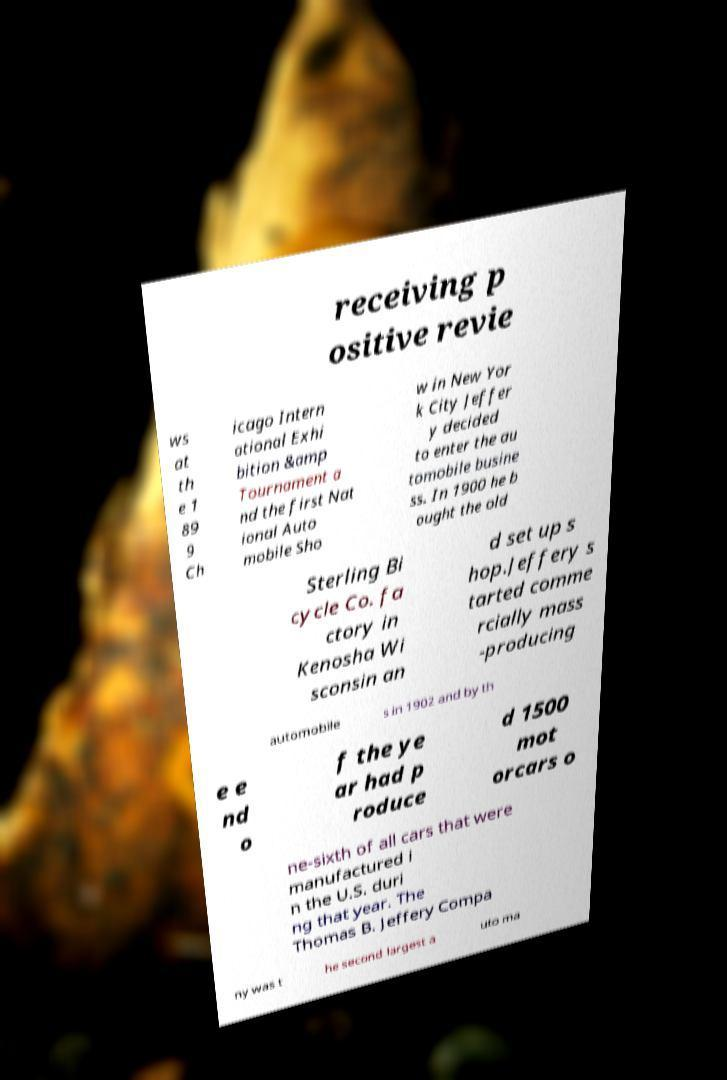Could you assist in decoding the text presented in this image and type it out clearly? receiving p ositive revie ws at th e 1 89 9 Ch icago Intern ational Exhi bition &amp Tournament a nd the first Nat ional Auto mobile Sho w in New Yor k City Jeffer y decided to enter the au tomobile busine ss. In 1900 he b ought the old Sterling Bi cycle Co. fa ctory in Kenosha Wi sconsin an d set up s hop.Jeffery s tarted comme rcially mass -producing automobile s in 1902 and by th e e nd o f the ye ar had p roduce d 1500 mot orcars o ne-sixth of all cars that were manufactured i n the U.S. duri ng that year. The Thomas B. Jeffery Compa ny was t he second largest a uto ma 